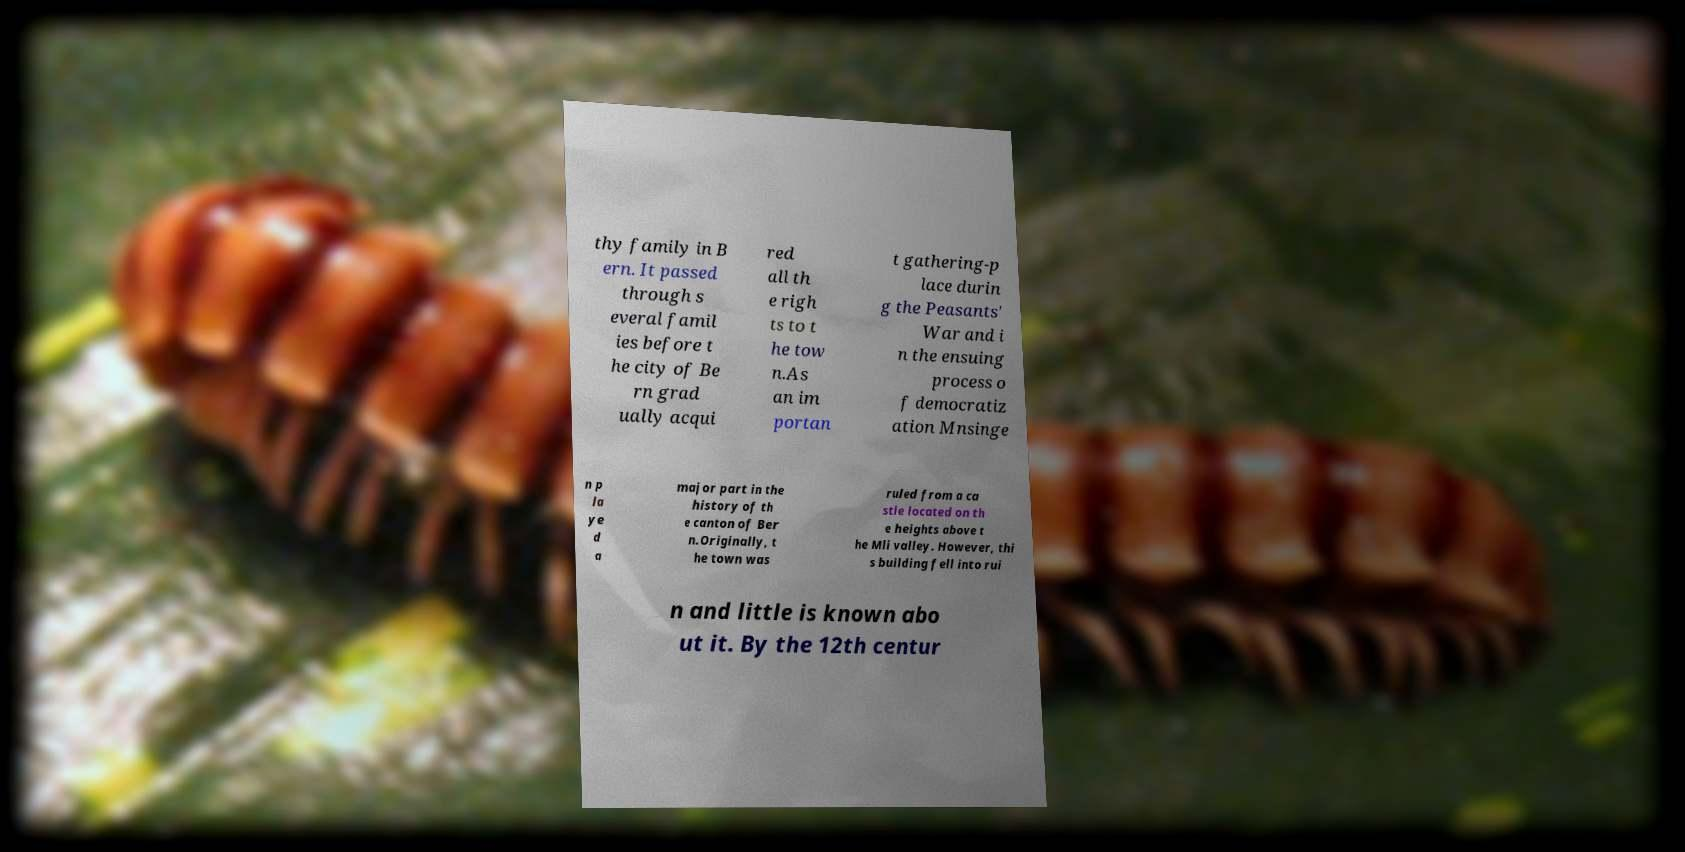I need the written content from this picture converted into text. Can you do that? thy family in B ern. It passed through s everal famil ies before t he city of Be rn grad ually acqui red all th e righ ts to t he tow n.As an im portan t gathering-p lace durin g the Peasants' War and i n the ensuing process o f democratiz ation Mnsinge n p la ye d a major part in the history of th e canton of Ber n.Originally, t he town was ruled from a ca stle located on th e heights above t he Mli valley. However, thi s building fell into rui n and little is known abo ut it. By the 12th centur 